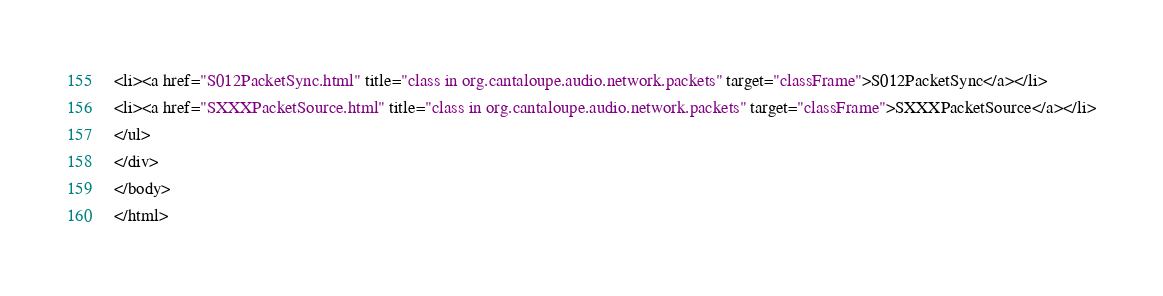<code> <loc_0><loc_0><loc_500><loc_500><_HTML_><li><a href="S012PacketSync.html" title="class in org.cantaloupe.audio.network.packets" target="classFrame">S012PacketSync</a></li>
<li><a href="SXXXPacketSource.html" title="class in org.cantaloupe.audio.network.packets" target="classFrame">SXXXPacketSource</a></li>
</ul>
</div>
</body>
</html>
</code> 